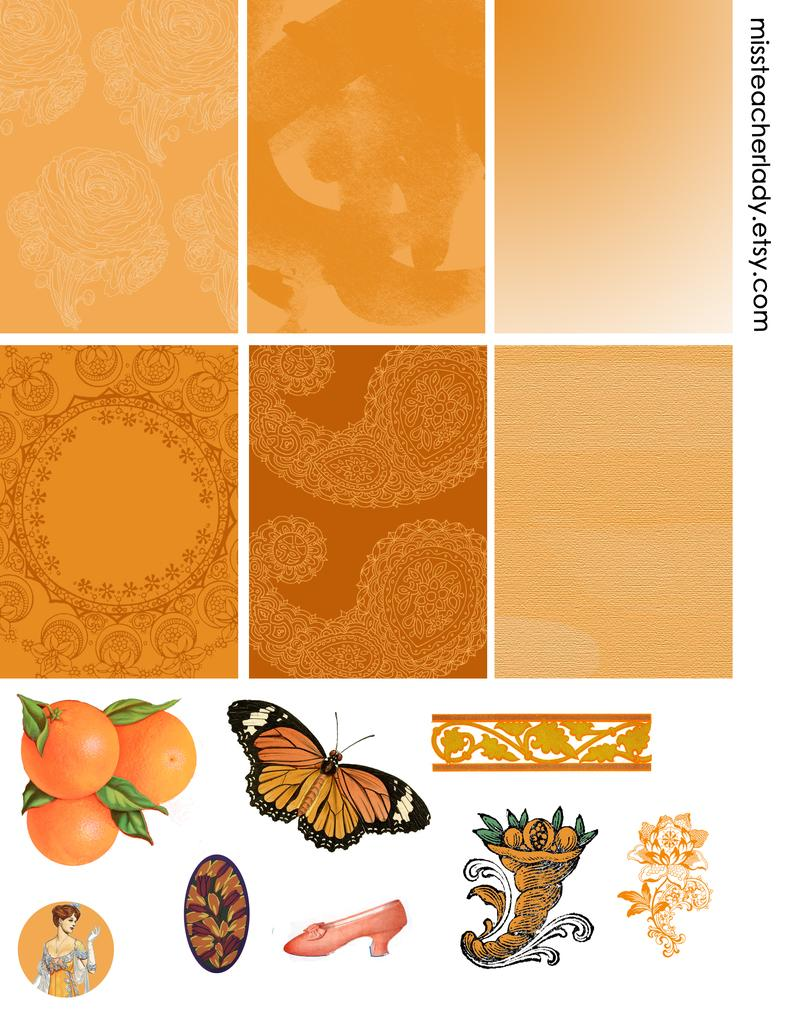What type of institution is depicted in the image? The image is of a college. What is the orange in the image used for? The purpose of the orange in the image is not specified, but it could be a decorative element or a snack. What type of creature is present in the image? There is a butterfly in the image. What can be seen in the image besides the college, orange, and butterfly? There are some designs and a shoe at the bottom of the image. What is the value of the shoe in the image? The value of the shoe in the image cannot be determined, as it is not a real shoe and there is no context provided for its value. 